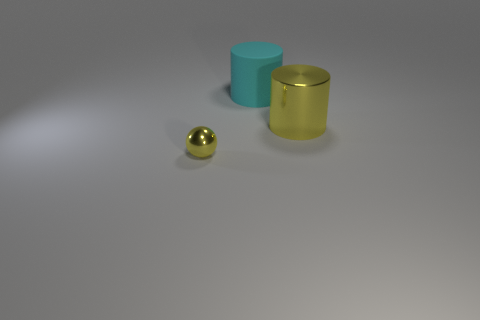Subtract all spheres. How many objects are left? 2 Add 1 metal cylinders. How many objects exist? 4 Subtract 1 spheres. How many spheres are left? 0 Subtract all red cylinders. Subtract all blue spheres. How many cylinders are left? 2 Subtract all blue cylinders. How many purple spheres are left? 0 Subtract all yellow metal spheres. Subtract all large rubber cylinders. How many objects are left? 1 Add 1 large cyan matte objects. How many large cyan matte objects are left? 2 Add 2 cyan cylinders. How many cyan cylinders exist? 3 Subtract all cyan cylinders. How many cylinders are left? 1 Subtract 0 gray balls. How many objects are left? 3 